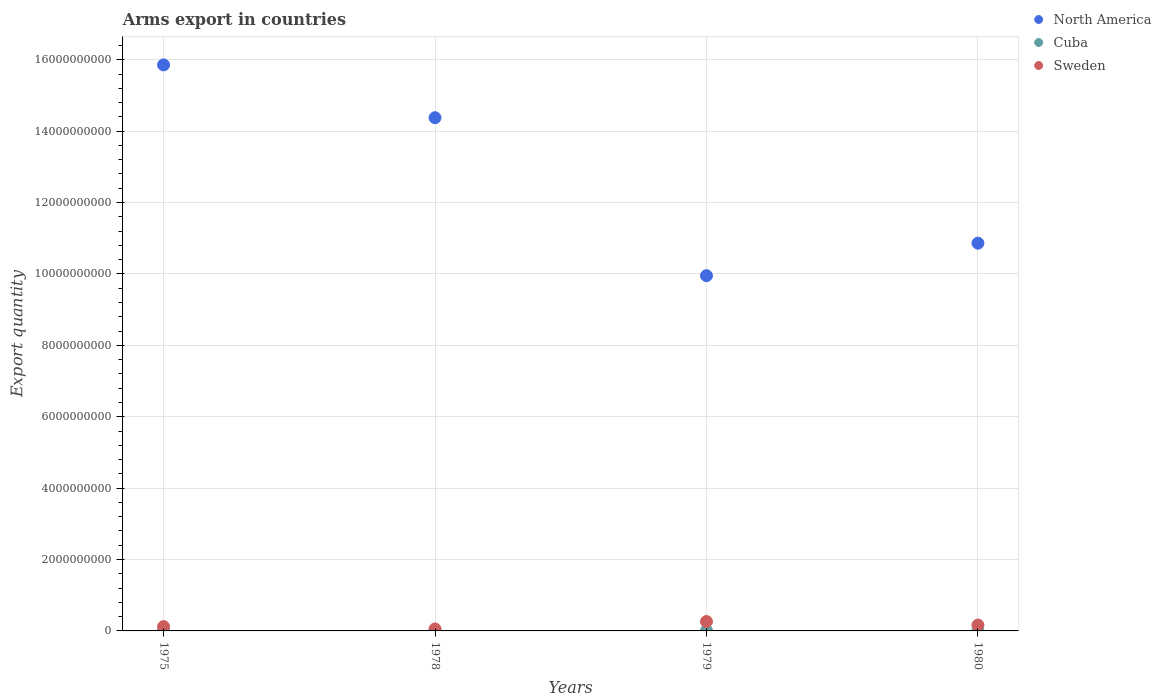What is the total arms export in Sweden in 1980?
Offer a terse response. 1.65e+08. Across all years, what is the maximum total arms export in Cuba?
Make the answer very short. 1.20e+07. Across all years, what is the minimum total arms export in Sweden?
Offer a terse response. 5.50e+07. In which year was the total arms export in North America maximum?
Give a very brief answer. 1975. In which year was the total arms export in North America minimum?
Provide a short and direct response. 1979. What is the total total arms export in Cuba in the graph?
Provide a short and direct response. 3.10e+07. What is the difference between the total arms export in Cuba in 1975 and that in 1978?
Offer a very short reply. -1.10e+07. What is the difference between the total arms export in North America in 1975 and the total arms export in Cuba in 1978?
Your answer should be compact. 1.58e+1. What is the average total arms export in Cuba per year?
Your answer should be compact. 7.75e+06. In the year 1978, what is the difference between the total arms export in Sweden and total arms export in North America?
Keep it short and to the point. -1.43e+1. What is the difference between the highest and the lowest total arms export in Cuba?
Offer a terse response. 1.10e+07. In how many years, is the total arms export in Cuba greater than the average total arms export in Cuba taken over all years?
Give a very brief answer. 3. Is it the case that in every year, the sum of the total arms export in North America and total arms export in Sweden  is greater than the total arms export in Cuba?
Keep it short and to the point. Yes. Is the total arms export in Sweden strictly greater than the total arms export in Cuba over the years?
Offer a very short reply. Yes. How many years are there in the graph?
Your response must be concise. 4. Are the values on the major ticks of Y-axis written in scientific E-notation?
Your response must be concise. No. Does the graph contain grids?
Ensure brevity in your answer.  Yes. Where does the legend appear in the graph?
Your response must be concise. Top right. How many legend labels are there?
Ensure brevity in your answer.  3. How are the legend labels stacked?
Keep it short and to the point. Vertical. What is the title of the graph?
Provide a succinct answer. Arms export in countries. Does "Micronesia" appear as one of the legend labels in the graph?
Offer a terse response. No. What is the label or title of the X-axis?
Make the answer very short. Years. What is the label or title of the Y-axis?
Make the answer very short. Export quantity. What is the Export quantity in North America in 1975?
Offer a terse response. 1.59e+1. What is the Export quantity of Sweden in 1975?
Provide a short and direct response. 1.21e+08. What is the Export quantity of North America in 1978?
Make the answer very short. 1.44e+1. What is the Export quantity of Sweden in 1978?
Offer a very short reply. 5.50e+07. What is the Export quantity of North America in 1979?
Ensure brevity in your answer.  9.95e+09. What is the Export quantity of Cuba in 1979?
Your answer should be very brief. 1.00e+07. What is the Export quantity in Sweden in 1979?
Your response must be concise. 2.63e+08. What is the Export quantity in North America in 1980?
Provide a succinct answer. 1.09e+1. What is the Export quantity in Cuba in 1980?
Offer a very short reply. 8.00e+06. What is the Export quantity of Sweden in 1980?
Offer a terse response. 1.65e+08. Across all years, what is the maximum Export quantity of North America?
Keep it short and to the point. 1.59e+1. Across all years, what is the maximum Export quantity in Cuba?
Keep it short and to the point. 1.20e+07. Across all years, what is the maximum Export quantity of Sweden?
Provide a succinct answer. 2.63e+08. Across all years, what is the minimum Export quantity in North America?
Provide a short and direct response. 9.95e+09. Across all years, what is the minimum Export quantity of Sweden?
Ensure brevity in your answer.  5.50e+07. What is the total Export quantity in North America in the graph?
Offer a terse response. 5.10e+1. What is the total Export quantity in Cuba in the graph?
Provide a short and direct response. 3.10e+07. What is the total Export quantity in Sweden in the graph?
Offer a very short reply. 6.04e+08. What is the difference between the Export quantity in North America in 1975 and that in 1978?
Your answer should be very brief. 1.48e+09. What is the difference between the Export quantity of Cuba in 1975 and that in 1978?
Your answer should be very brief. -1.10e+07. What is the difference between the Export quantity of Sweden in 1975 and that in 1978?
Provide a succinct answer. 6.60e+07. What is the difference between the Export quantity in North America in 1975 and that in 1979?
Offer a very short reply. 5.90e+09. What is the difference between the Export quantity of Cuba in 1975 and that in 1979?
Ensure brevity in your answer.  -9.00e+06. What is the difference between the Export quantity in Sweden in 1975 and that in 1979?
Your response must be concise. -1.42e+08. What is the difference between the Export quantity in North America in 1975 and that in 1980?
Ensure brevity in your answer.  5.00e+09. What is the difference between the Export quantity in Cuba in 1975 and that in 1980?
Your answer should be very brief. -7.00e+06. What is the difference between the Export quantity in Sweden in 1975 and that in 1980?
Offer a terse response. -4.40e+07. What is the difference between the Export quantity in North America in 1978 and that in 1979?
Offer a very short reply. 4.42e+09. What is the difference between the Export quantity of Cuba in 1978 and that in 1979?
Your answer should be very brief. 2.00e+06. What is the difference between the Export quantity in Sweden in 1978 and that in 1979?
Provide a succinct answer. -2.08e+08. What is the difference between the Export quantity in North America in 1978 and that in 1980?
Make the answer very short. 3.52e+09. What is the difference between the Export quantity in Cuba in 1978 and that in 1980?
Keep it short and to the point. 4.00e+06. What is the difference between the Export quantity in Sweden in 1978 and that in 1980?
Keep it short and to the point. -1.10e+08. What is the difference between the Export quantity in North America in 1979 and that in 1980?
Offer a very short reply. -9.10e+08. What is the difference between the Export quantity of Sweden in 1979 and that in 1980?
Provide a succinct answer. 9.80e+07. What is the difference between the Export quantity of North America in 1975 and the Export quantity of Cuba in 1978?
Provide a succinct answer. 1.58e+1. What is the difference between the Export quantity in North America in 1975 and the Export quantity in Sweden in 1978?
Your answer should be very brief. 1.58e+1. What is the difference between the Export quantity in Cuba in 1975 and the Export quantity in Sweden in 1978?
Your answer should be compact. -5.40e+07. What is the difference between the Export quantity in North America in 1975 and the Export quantity in Cuba in 1979?
Provide a short and direct response. 1.58e+1. What is the difference between the Export quantity in North America in 1975 and the Export quantity in Sweden in 1979?
Offer a very short reply. 1.56e+1. What is the difference between the Export quantity of Cuba in 1975 and the Export quantity of Sweden in 1979?
Your answer should be very brief. -2.62e+08. What is the difference between the Export quantity in North America in 1975 and the Export quantity in Cuba in 1980?
Your answer should be compact. 1.58e+1. What is the difference between the Export quantity in North America in 1975 and the Export quantity in Sweden in 1980?
Your response must be concise. 1.57e+1. What is the difference between the Export quantity in Cuba in 1975 and the Export quantity in Sweden in 1980?
Your answer should be compact. -1.64e+08. What is the difference between the Export quantity in North America in 1978 and the Export quantity in Cuba in 1979?
Provide a short and direct response. 1.44e+1. What is the difference between the Export quantity in North America in 1978 and the Export quantity in Sweden in 1979?
Make the answer very short. 1.41e+1. What is the difference between the Export quantity of Cuba in 1978 and the Export quantity of Sweden in 1979?
Give a very brief answer. -2.51e+08. What is the difference between the Export quantity of North America in 1978 and the Export quantity of Cuba in 1980?
Keep it short and to the point. 1.44e+1. What is the difference between the Export quantity of North America in 1978 and the Export quantity of Sweden in 1980?
Give a very brief answer. 1.42e+1. What is the difference between the Export quantity in Cuba in 1978 and the Export quantity in Sweden in 1980?
Provide a short and direct response. -1.53e+08. What is the difference between the Export quantity in North America in 1979 and the Export quantity in Cuba in 1980?
Keep it short and to the point. 9.94e+09. What is the difference between the Export quantity of North America in 1979 and the Export quantity of Sweden in 1980?
Provide a short and direct response. 9.79e+09. What is the difference between the Export quantity in Cuba in 1979 and the Export quantity in Sweden in 1980?
Your answer should be very brief. -1.55e+08. What is the average Export quantity of North America per year?
Provide a short and direct response. 1.28e+1. What is the average Export quantity of Cuba per year?
Your answer should be compact. 7.75e+06. What is the average Export quantity in Sweden per year?
Make the answer very short. 1.51e+08. In the year 1975, what is the difference between the Export quantity in North America and Export quantity in Cuba?
Your response must be concise. 1.59e+1. In the year 1975, what is the difference between the Export quantity in North America and Export quantity in Sweden?
Offer a terse response. 1.57e+1. In the year 1975, what is the difference between the Export quantity of Cuba and Export quantity of Sweden?
Offer a very short reply. -1.20e+08. In the year 1978, what is the difference between the Export quantity in North America and Export quantity in Cuba?
Offer a terse response. 1.44e+1. In the year 1978, what is the difference between the Export quantity of North America and Export quantity of Sweden?
Give a very brief answer. 1.43e+1. In the year 1978, what is the difference between the Export quantity in Cuba and Export quantity in Sweden?
Your answer should be compact. -4.30e+07. In the year 1979, what is the difference between the Export quantity in North America and Export quantity in Cuba?
Offer a very short reply. 9.94e+09. In the year 1979, what is the difference between the Export quantity in North America and Export quantity in Sweden?
Your response must be concise. 9.69e+09. In the year 1979, what is the difference between the Export quantity of Cuba and Export quantity of Sweden?
Keep it short and to the point. -2.53e+08. In the year 1980, what is the difference between the Export quantity in North America and Export quantity in Cuba?
Provide a short and direct response. 1.09e+1. In the year 1980, what is the difference between the Export quantity in North America and Export quantity in Sweden?
Provide a succinct answer. 1.07e+1. In the year 1980, what is the difference between the Export quantity of Cuba and Export quantity of Sweden?
Provide a succinct answer. -1.57e+08. What is the ratio of the Export quantity in North America in 1975 to that in 1978?
Your response must be concise. 1.1. What is the ratio of the Export quantity in Cuba in 1975 to that in 1978?
Keep it short and to the point. 0.08. What is the ratio of the Export quantity of North America in 1975 to that in 1979?
Your answer should be very brief. 1.59. What is the ratio of the Export quantity in Sweden in 1975 to that in 1979?
Ensure brevity in your answer.  0.46. What is the ratio of the Export quantity in North America in 1975 to that in 1980?
Offer a very short reply. 1.46. What is the ratio of the Export quantity in Sweden in 1975 to that in 1980?
Your answer should be very brief. 0.73. What is the ratio of the Export quantity in North America in 1978 to that in 1979?
Your response must be concise. 1.44. What is the ratio of the Export quantity in Sweden in 1978 to that in 1979?
Keep it short and to the point. 0.21. What is the ratio of the Export quantity in North America in 1978 to that in 1980?
Give a very brief answer. 1.32. What is the ratio of the Export quantity of North America in 1979 to that in 1980?
Provide a short and direct response. 0.92. What is the ratio of the Export quantity of Sweden in 1979 to that in 1980?
Provide a short and direct response. 1.59. What is the difference between the highest and the second highest Export quantity of North America?
Give a very brief answer. 1.48e+09. What is the difference between the highest and the second highest Export quantity in Cuba?
Make the answer very short. 2.00e+06. What is the difference between the highest and the second highest Export quantity in Sweden?
Provide a succinct answer. 9.80e+07. What is the difference between the highest and the lowest Export quantity of North America?
Provide a short and direct response. 5.90e+09. What is the difference between the highest and the lowest Export quantity in Cuba?
Your answer should be very brief. 1.10e+07. What is the difference between the highest and the lowest Export quantity in Sweden?
Offer a terse response. 2.08e+08. 